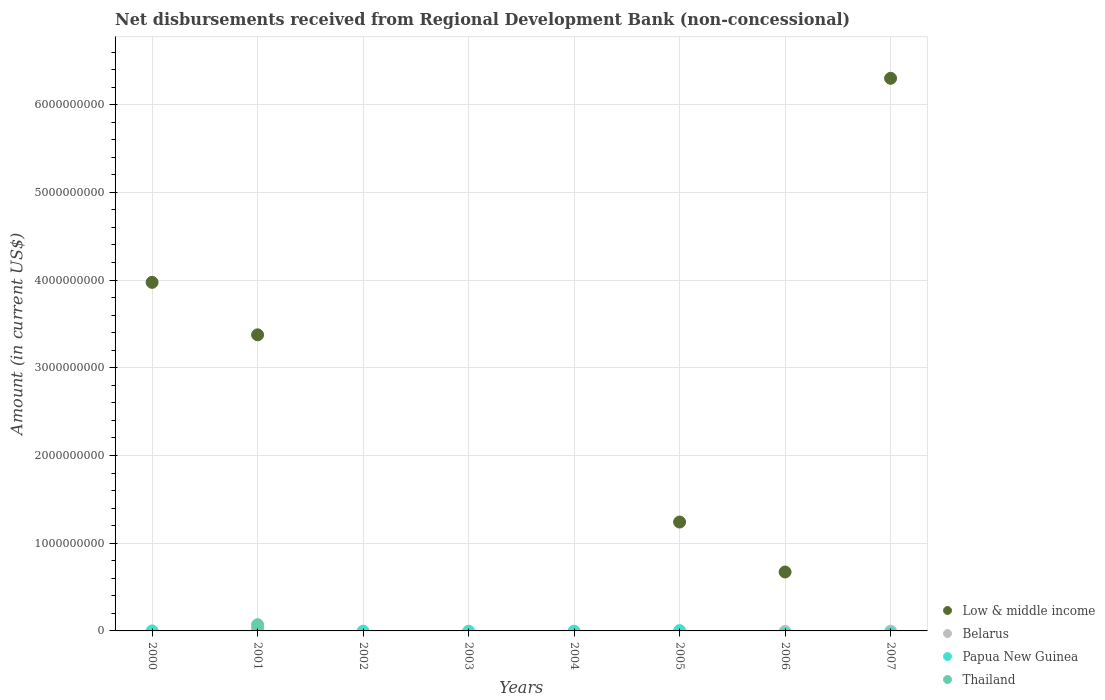How many different coloured dotlines are there?
Offer a very short reply. 3. What is the amount of disbursements received from Regional Development Bank in Thailand in 2003?
Your response must be concise. 0. Across all years, what is the maximum amount of disbursements received from Regional Development Bank in Thailand?
Your answer should be very brief. 7.05e+07. Across all years, what is the minimum amount of disbursements received from Regional Development Bank in Belarus?
Provide a succinct answer. 0. What is the total amount of disbursements received from Regional Development Bank in Low & middle income in the graph?
Make the answer very short. 1.56e+1. What is the average amount of disbursements received from Regional Development Bank in Thailand per year?
Give a very brief answer. 8.82e+06. In the year 2001, what is the difference between the amount of disbursements received from Regional Development Bank in Low & middle income and amount of disbursements received from Regional Development Bank in Papua New Guinea?
Give a very brief answer. 3.35e+09. What is the ratio of the amount of disbursements received from Regional Development Bank in Low & middle income in 2000 to that in 2001?
Keep it short and to the point. 1.18. What is the difference between the highest and the second highest amount of disbursements received from Regional Development Bank in Low & middle income?
Your response must be concise. 2.33e+09. What is the difference between the highest and the lowest amount of disbursements received from Regional Development Bank in Low & middle income?
Ensure brevity in your answer.  6.30e+09. Is it the case that in every year, the sum of the amount of disbursements received from Regional Development Bank in Thailand and amount of disbursements received from Regional Development Bank in Papua New Guinea  is greater than the sum of amount of disbursements received from Regional Development Bank in Low & middle income and amount of disbursements received from Regional Development Bank in Belarus?
Give a very brief answer. No. Is it the case that in every year, the sum of the amount of disbursements received from Regional Development Bank in Papua New Guinea and amount of disbursements received from Regional Development Bank in Thailand  is greater than the amount of disbursements received from Regional Development Bank in Low & middle income?
Your response must be concise. No. Is the amount of disbursements received from Regional Development Bank in Low & middle income strictly greater than the amount of disbursements received from Regional Development Bank in Thailand over the years?
Offer a very short reply. No. How many dotlines are there?
Keep it short and to the point. 3. How many years are there in the graph?
Provide a short and direct response. 8. What is the difference between two consecutive major ticks on the Y-axis?
Offer a very short reply. 1.00e+09. How are the legend labels stacked?
Keep it short and to the point. Vertical. What is the title of the graph?
Your answer should be compact. Net disbursements received from Regional Development Bank (non-concessional). Does "China" appear as one of the legend labels in the graph?
Your answer should be very brief. No. What is the label or title of the X-axis?
Your answer should be compact. Years. What is the label or title of the Y-axis?
Ensure brevity in your answer.  Amount (in current US$). What is the Amount (in current US$) of Low & middle income in 2000?
Offer a very short reply. 3.97e+09. What is the Amount (in current US$) in Belarus in 2000?
Give a very brief answer. 0. What is the Amount (in current US$) of Papua New Guinea in 2000?
Make the answer very short. 8000. What is the Amount (in current US$) of Thailand in 2000?
Provide a short and direct response. 0. What is the Amount (in current US$) in Low & middle income in 2001?
Offer a very short reply. 3.38e+09. What is the Amount (in current US$) in Papua New Guinea in 2001?
Offer a very short reply. 3.03e+07. What is the Amount (in current US$) in Thailand in 2001?
Keep it short and to the point. 7.05e+07. What is the Amount (in current US$) in Belarus in 2002?
Keep it short and to the point. 0. What is the Amount (in current US$) of Low & middle income in 2003?
Provide a succinct answer. 0. What is the Amount (in current US$) in Papua New Guinea in 2004?
Give a very brief answer. 0. What is the Amount (in current US$) of Thailand in 2004?
Your answer should be very brief. 0. What is the Amount (in current US$) of Low & middle income in 2005?
Give a very brief answer. 1.24e+09. What is the Amount (in current US$) of Belarus in 2005?
Give a very brief answer. 0. What is the Amount (in current US$) of Papua New Guinea in 2005?
Provide a succinct answer. 3.54e+06. What is the Amount (in current US$) in Low & middle income in 2006?
Your response must be concise. 6.72e+08. What is the Amount (in current US$) in Papua New Guinea in 2006?
Your answer should be very brief. 0. What is the Amount (in current US$) in Low & middle income in 2007?
Your answer should be compact. 6.30e+09. What is the Amount (in current US$) of Papua New Guinea in 2007?
Offer a terse response. 0. Across all years, what is the maximum Amount (in current US$) in Low & middle income?
Make the answer very short. 6.30e+09. Across all years, what is the maximum Amount (in current US$) in Papua New Guinea?
Give a very brief answer. 3.03e+07. Across all years, what is the maximum Amount (in current US$) of Thailand?
Give a very brief answer. 7.05e+07. Across all years, what is the minimum Amount (in current US$) of Low & middle income?
Keep it short and to the point. 0. What is the total Amount (in current US$) of Low & middle income in the graph?
Make the answer very short. 1.56e+1. What is the total Amount (in current US$) of Belarus in the graph?
Your response must be concise. 0. What is the total Amount (in current US$) of Papua New Guinea in the graph?
Provide a succinct answer. 3.38e+07. What is the total Amount (in current US$) of Thailand in the graph?
Your answer should be very brief. 7.05e+07. What is the difference between the Amount (in current US$) in Low & middle income in 2000 and that in 2001?
Your answer should be compact. 5.98e+08. What is the difference between the Amount (in current US$) in Papua New Guinea in 2000 and that in 2001?
Keep it short and to the point. -3.03e+07. What is the difference between the Amount (in current US$) of Low & middle income in 2000 and that in 2005?
Make the answer very short. 2.73e+09. What is the difference between the Amount (in current US$) in Papua New Guinea in 2000 and that in 2005?
Offer a terse response. -3.54e+06. What is the difference between the Amount (in current US$) in Low & middle income in 2000 and that in 2006?
Your answer should be very brief. 3.30e+09. What is the difference between the Amount (in current US$) in Low & middle income in 2000 and that in 2007?
Provide a short and direct response. -2.33e+09. What is the difference between the Amount (in current US$) of Low & middle income in 2001 and that in 2005?
Your response must be concise. 2.13e+09. What is the difference between the Amount (in current US$) in Papua New Guinea in 2001 and that in 2005?
Offer a terse response. 2.67e+07. What is the difference between the Amount (in current US$) of Low & middle income in 2001 and that in 2006?
Make the answer very short. 2.70e+09. What is the difference between the Amount (in current US$) in Low & middle income in 2001 and that in 2007?
Give a very brief answer. -2.92e+09. What is the difference between the Amount (in current US$) of Low & middle income in 2005 and that in 2006?
Give a very brief answer. 5.70e+08. What is the difference between the Amount (in current US$) of Low & middle income in 2005 and that in 2007?
Your response must be concise. -5.06e+09. What is the difference between the Amount (in current US$) in Low & middle income in 2006 and that in 2007?
Offer a terse response. -5.63e+09. What is the difference between the Amount (in current US$) of Low & middle income in 2000 and the Amount (in current US$) of Papua New Guinea in 2001?
Keep it short and to the point. 3.94e+09. What is the difference between the Amount (in current US$) of Low & middle income in 2000 and the Amount (in current US$) of Thailand in 2001?
Ensure brevity in your answer.  3.90e+09. What is the difference between the Amount (in current US$) of Papua New Guinea in 2000 and the Amount (in current US$) of Thailand in 2001?
Keep it short and to the point. -7.05e+07. What is the difference between the Amount (in current US$) of Low & middle income in 2000 and the Amount (in current US$) of Papua New Guinea in 2005?
Make the answer very short. 3.97e+09. What is the difference between the Amount (in current US$) in Low & middle income in 2001 and the Amount (in current US$) in Papua New Guinea in 2005?
Keep it short and to the point. 3.37e+09. What is the average Amount (in current US$) in Low & middle income per year?
Make the answer very short. 1.95e+09. What is the average Amount (in current US$) in Belarus per year?
Provide a succinct answer. 0. What is the average Amount (in current US$) of Papua New Guinea per year?
Offer a very short reply. 4.23e+06. What is the average Amount (in current US$) of Thailand per year?
Make the answer very short. 8.82e+06. In the year 2000, what is the difference between the Amount (in current US$) in Low & middle income and Amount (in current US$) in Papua New Guinea?
Make the answer very short. 3.97e+09. In the year 2001, what is the difference between the Amount (in current US$) of Low & middle income and Amount (in current US$) of Papua New Guinea?
Your response must be concise. 3.35e+09. In the year 2001, what is the difference between the Amount (in current US$) of Low & middle income and Amount (in current US$) of Thailand?
Ensure brevity in your answer.  3.31e+09. In the year 2001, what is the difference between the Amount (in current US$) in Papua New Guinea and Amount (in current US$) in Thailand?
Keep it short and to the point. -4.03e+07. In the year 2005, what is the difference between the Amount (in current US$) in Low & middle income and Amount (in current US$) in Papua New Guinea?
Your response must be concise. 1.24e+09. What is the ratio of the Amount (in current US$) in Low & middle income in 2000 to that in 2001?
Give a very brief answer. 1.18. What is the ratio of the Amount (in current US$) in Low & middle income in 2000 to that in 2005?
Your response must be concise. 3.2. What is the ratio of the Amount (in current US$) of Papua New Guinea in 2000 to that in 2005?
Give a very brief answer. 0. What is the ratio of the Amount (in current US$) of Low & middle income in 2000 to that in 2006?
Offer a terse response. 5.92. What is the ratio of the Amount (in current US$) in Low & middle income in 2000 to that in 2007?
Your answer should be very brief. 0.63. What is the ratio of the Amount (in current US$) of Low & middle income in 2001 to that in 2005?
Your answer should be very brief. 2.72. What is the ratio of the Amount (in current US$) of Papua New Guinea in 2001 to that in 2005?
Provide a succinct answer. 8.54. What is the ratio of the Amount (in current US$) in Low & middle income in 2001 to that in 2006?
Your answer should be compact. 5.03. What is the ratio of the Amount (in current US$) of Low & middle income in 2001 to that in 2007?
Your response must be concise. 0.54. What is the ratio of the Amount (in current US$) in Low & middle income in 2005 to that in 2006?
Your answer should be compact. 1.85. What is the ratio of the Amount (in current US$) in Low & middle income in 2005 to that in 2007?
Your answer should be very brief. 0.2. What is the ratio of the Amount (in current US$) of Low & middle income in 2006 to that in 2007?
Give a very brief answer. 0.11. What is the difference between the highest and the second highest Amount (in current US$) in Low & middle income?
Provide a short and direct response. 2.33e+09. What is the difference between the highest and the second highest Amount (in current US$) of Papua New Guinea?
Provide a short and direct response. 2.67e+07. What is the difference between the highest and the lowest Amount (in current US$) of Low & middle income?
Give a very brief answer. 6.30e+09. What is the difference between the highest and the lowest Amount (in current US$) of Papua New Guinea?
Keep it short and to the point. 3.03e+07. What is the difference between the highest and the lowest Amount (in current US$) in Thailand?
Give a very brief answer. 7.05e+07. 